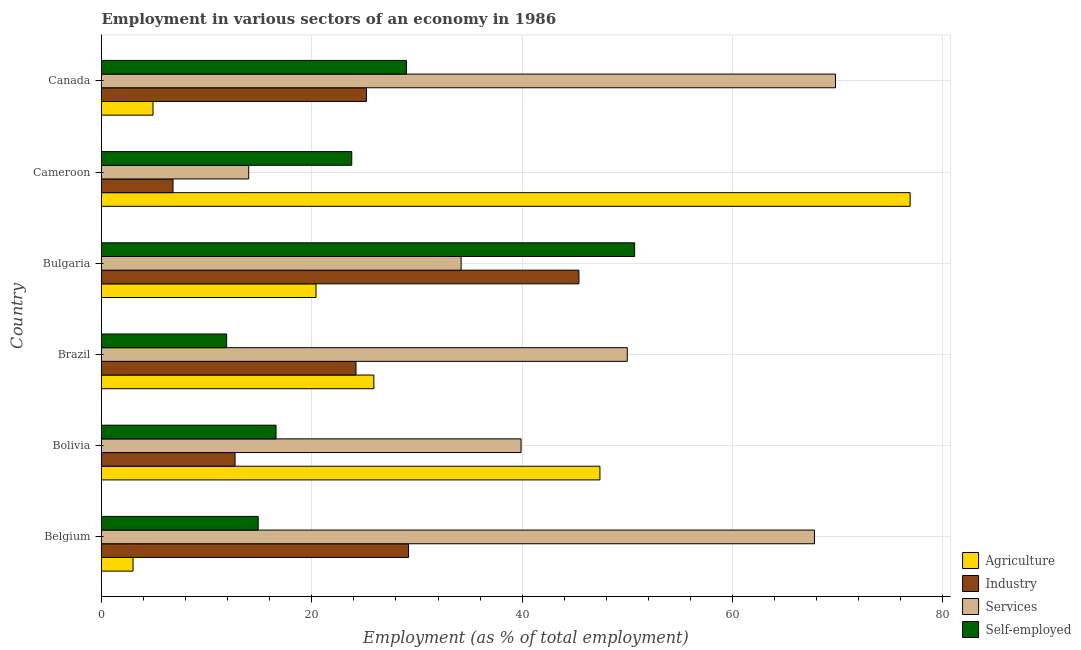How many groups of bars are there?
Ensure brevity in your answer.  6. Are the number of bars on each tick of the Y-axis equal?
Ensure brevity in your answer.  Yes. How many bars are there on the 4th tick from the bottom?
Your answer should be compact. 4. What is the label of the 5th group of bars from the top?
Your response must be concise. Bolivia. What is the percentage of self employed workers in Belgium?
Make the answer very short. 14.9. Across all countries, what is the maximum percentage of workers in industry?
Provide a short and direct response. 45.4. Across all countries, what is the minimum percentage of self employed workers?
Ensure brevity in your answer.  11.9. In which country was the percentage of workers in services maximum?
Give a very brief answer. Canada. In which country was the percentage of workers in services minimum?
Offer a terse response. Cameroon. What is the total percentage of workers in agriculture in the graph?
Make the answer very short. 178.5. What is the difference between the percentage of workers in services in Brazil and that in Canada?
Keep it short and to the point. -19.8. What is the difference between the percentage of workers in agriculture in Bulgaria and the percentage of self employed workers in Bolivia?
Provide a short and direct response. 3.8. What is the average percentage of self employed workers per country?
Offer a terse response. 24.48. What is the difference between the percentage of workers in agriculture and percentage of workers in industry in Belgium?
Offer a terse response. -26.2. What is the ratio of the percentage of workers in services in Bolivia to that in Bulgaria?
Offer a terse response. 1.17. Is the percentage of self employed workers in Brazil less than that in Bulgaria?
Your answer should be compact. Yes. Is the difference between the percentage of workers in services in Belgium and Cameroon greater than the difference between the percentage of workers in agriculture in Belgium and Cameroon?
Provide a short and direct response. Yes. What is the difference between the highest and the second highest percentage of workers in services?
Your answer should be compact. 2. What is the difference between the highest and the lowest percentage of self employed workers?
Keep it short and to the point. 38.8. In how many countries, is the percentage of self employed workers greater than the average percentage of self employed workers taken over all countries?
Offer a terse response. 2. Is the sum of the percentage of workers in services in Belgium and Bolivia greater than the maximum percentage of workers in agriculture across all countries?
Provide a short and direct response. Yes. What does the 3rd bar from the top in Cameroon represents?
Provide a short and direct response. Industry. What does the 2nd bar from the bottom in Bulgaria represents?
Make the answer very short. Industry. Is it the case that in every country, the sum of the percentage of workers in agriculture and percentage of workers in industry is greater than the percentage of workers in services?
Give a very brief answer. No. How many bars are there?
Offer a terse response. 24. How many countries are there in the graph?
Keep it short and to the point. 6. What is the difference between two consecutive major ticks on the X-axis?
Give a very brief answer. 20. Are the values on the major ticks of X-axis written in scientific E-notation?
Offer a terse response. No. Does the graph contain any zero values?
Keep it short and to the point. No. How are the legend labels stacked?
Provide a succinct answer. Vertical. What is the title of the graph?
Give a very brief answer. Employment in various sectors of an economy in 1986. Does "Secondary schools" appear as one of the legend labels in the graph?
Keep it short and to the point. No. What is the label or title of the X-axis?
Ensure brevity in your answer.  Employment (as % of total employment). What is the label or title of the Y-axis?
Keep it short and to the point. Country. What is the Employment (as % of total employment) in Industry in Belgium?
Provide a short and direct response. 29.2. What is the Employment (as % of total employment) in Services in Belgium?
Provide a succinct answer. 67.8. What is the Employment (as % of total employment) in Self-employed in Belgium?
Your answer should be compact. 14.9. What is the Employment (as % of total employment) of Agriculture in Bolivia?
Make the answer very short. 47.4. What is the Employment (as % of total employment) in Industry in Bolivia?
Provide a short and direct response. 12.7. What is the Employment (as % of total employment) in Services in Bolivia?
Provide a short and direct response. 39.9. What is the Employment (as % of total employment) in Self-employed in Bolivia?
Your response must be concise. 16.6. What is the Employment (as % of total employment) of Agriculture in Brazil?
Ensure brevity in your answer.  25.9. What is the Employment (as % of total employment) of Industry in Brazil?
Offer a very short reply. 24.2. What is the Employment (as % of total employment) of Self-employed in Brazil?
Offer a terse response. 11.9. What is the Employment (as % of total employment) of Agriculture in Bulgaria?
Offer a terse response. 20.4. What is the Employment (as % of total employment) in Industry in Bulgaria?
Provide a succinct answer. 45.4. What is the Employment (as % of total employment) of Services in Bulgaria?
Your answer should be very brief. 34.2. What is the Employment (as % of total employment) in Self-employed in Bulgaria?
Your answer should be very brief. 50.7. What is the Employment (as % of total employment) of Agriculture in Cameroon?
Your answer should be compact. 76.9. What is the Employment (as % of total employment) in Industry in Cameroon?
Ensure brevity in your answer.  6.8. What is the Employment (as % of total employment) of Self-employed in Cameroon?
Your response must be concise. 23.8. What is the Employment (as % of total employment) of Agriculture in Canada?
Make the answer very short. 4.9. What is the Employment (as % of total employment) of Industry in Canada?
Make the answer very short. 25.2. What is the Employment (as % of total employment) of Services in Canada?
Your answer should be very brief. 69.8. What is the Employment (as % of total employment) in Self-employed in Canada?
Give a very brief answer. 29. Across all countries, what is the maximum Employment (as % of total employment) of Agriculture?
Provide a succinct answer. 76.9. Across all countries, what is the maximum Employment (as % of total employment) of Industry?
Offer a terse response. 45.4. Across all countries, what is the maximum Employment (as % of total employment) in Services?
Your answer should be compact. 69.8. Across all countries, what is the maximum Employment (as % of total employment) of Self-employed?
Your answer should be compact. 50.7. Across all countries, what is the minimum Employment (as % of total employment) of Industry?
Give a very brief answer. 6.8. Across all countries, what is the minimum Employment (as % of total employment) of Services?
Keep it short and to the point. 14. Across all countries, what is the minimum Employment (as % of total employment) in Self-employed?
Offer a very short reply. 11.9. What is the total Employment (as % of total employment) of Agriculture in the graph?
Offer a terse response. 178.5. What is the total Employment (as % of total employment) of Industry in the graph?
Provide a succinct answer. 143.5. What is the total Employment (as % of total employment) of Services in the graph?
Keep it short and to the point. 275.7. What is the total Employment (as % of total employment) in Self-employed in the graph?
Your answer should be compact. 146.9. What is the difference between the Employment (as % of total employment) of Agriculture in Belgium and that in Bolivia?
Provide a succinct answer. -44.4. What is the difference between the Employment (as % of total employment) in Industry in Belgium and that in Bolivia?
Ensure brevity in your answer.  16.5. What is the difference between the Employment (as % of total employment) in Services in Belgium and that in Bolivia?
Offer a very short reply. 27.9. What is the difference between the Employment (as % of total employment) in Self-employed in Belgium and that in Bolivia?
Your response must be concise. -1.7. What is the difference between the Employment (as % of total employment) of Agriculture in Belgium and that in Brazil?
Keep it short and to the point. -22.9. What is the difference between the Employment (as % of total employment) in Agriculture in Belgium and that in Bulgaria?
Your answer should be very brief. -17.4. What is the difference between the Employment (as % of total employment) of Industry in Belgium and that in Bulgaria?
Ensure brevity in your answer.  -16.2. What is the difference between the Employment (as % of total employment) of Services in Belgium and that in Bulgaria?
Keep it short and to the point. 33.6. What is the difference between the Employment (as % of total employment) of Self-employed in Belgium and that in Bulgaria?
Give a very brief answer. -35.8. What is the difference between the Employment (as % of total employment) of Agriculture in Belgium and that in Cameroon?
Your answer should be very brief. -73.9. What is the difference between the Employment (as % of total employment) of Industry in Belgium and that in Cameroon?
Ensure brevity in your answer.  22.4. What is the difference between the Employment (as % of total employment) of Services in Belgium and that in Cameroon?
Keep it short and to the point. 53.8. What is the difference between the Employment (as % of total employment) in Self-employed in Belgium and that in Cameroon?
Offer a very short reply. -8.9. What is the difference between the Employment (as % of total employment) of Self-employed in Belgium and that in Canada?
Keep it short and to the point. -14.1. What is the difference between the Employment (as % of total employment) of Services in Bolivia and that in Brazil?
Provide a succinct answer. -10.1. What is the difference between the Employment (as % of total employment) of Agriculture in Bolivia and that in Bulgaria?
Give a very brief answer. 27. What is the difference between the Employment (as % of total employment) in Industry in Bolivia and that in Bulgaria?
Provide a succinct answer. -32.7. What is the difference between the Employment (as % of total employment) of Services in Bolivia and that in Bulgaria?
Your response must be concise. 5.7. What is the difference between the Employment (as % of total employment) in Self-employed in Bolivia and that in Bulgaria?
Offer a very short reply. -34.1. What is the difference between the Employment (as % of total employment) of Agriculture in Bolivia and that in Cameroon?
Offer a very short reply. -29.5. What is the difference between the Employment (as % of total employment) in Services in Bolivia and that in Cameroon?
Ensure brevity in your answer.  25.9. What is the difference between the Employment (as % of total employment) in Agriculture in Bolivia and that in Canada?
Make the answer very short. 42.5. What is the difference between the Employment (as % of total employment) in Services in Bolivia and that in Canada?
Your answer should be very brief. -29.9. What is the difference between the Employment (as % of total employment) in Self-employed in Bolivia and that in Canada?
Keep it short and to the point. -12.4. What is the difference between the Employment (as % of total employment) in Agriculture in Brazil and that in Bulgaria?
Give a very brief answer. 5.5. What is the difference between the Employment (as % of total employment) of Industry in Brazil and that in Bulgaria?
Ensure brevity in your answer.  -21.2. What is the difference between the Employment (as % of total employment) of Self-employed in Brazil and that in Bulgaria?
Your answer should be very brief. -38.8. What is the difference between the Employment (as % of total employment) in Agriculture in Brazil and that in Cameroon?
Your response must be concise. -51. What is the difference between the Employment (as % of total employment) of Agriculture in Brazil and that in Canada?
Offer a terse response. 21. What is the difference between the Employment (as % of total employment) of Industry in Brazil and that in Canada?
Your answer should be very brief. -1. What is the difference between the Employment (as % of total employment) of Services in Brazil and that in Canada?
Offer a very short reply. -19.8. What is the difference between the Employment (as % of total employment) in Self-employed in Brazil and that in Canada?
Your response must be concise. -17.1. What is the difference between the Employment (as % of total employment) of Agriculture in Bulgaria and that in Cameroon?
Your answer should be very brief. -56.5. What is the difference between the Employment (as % of total employment) in Industry in Bulgaria and that in Cameroon?
Keep it short and to the point. 38.6. What is the difference between the Employment (as % of total employment) in Services in Bulgaria and that in Cameroon?
Ensure brevity in your answer.  20.2. What is the difference between the Employment (as % of total employment) in Self-employed in Bulgaria and that in Cameroon?
Ensure brevity in your answer.  26.9. What is the difference between the Employment (as % of total employment) of Agriculture in Bulgaria and that in Canada?
Your answer should be compact. 15.5. What is the difference between the Employment (as % of total employment) in Industry in Bulgaria and that in Canada?
Your answer should be compact. 20.2. What is the difference between the Employment (as % of total employment) of Services in Bulgaria and that in Canada?
Offer a very short reply. -35.6. What is the difference between the Employment (as % of total employment) of Self-employed in Bulgaria and that in Canada?
Give a very brief answer. 21.7. What is the difference between the Employment (as % of total employment) in Agriculture in Cameroon and that in Canada?
Make the answer very short. 72. What is the difference between the Employment (as % of total employment) of Industry in Cameroon and that in Canada?
Give a very brief answer. -18.4. What is the difference between the Employment (as % of total employment) in Services in Cameroon and that in Canada?
Provide a succinct answer. -55.8. What is the difference between the Employment (as % of total employment) of Self-employed in Cameroon and that in Canada?
Provide a succinct answer. -5.2. What is the difference between the Employment (as % of total employment) in Agriculture in Belgium and the Employment (as % of total employment) in Services in Bolivia?
Provide a short and direct response. -36.9. What is the difference between the Employment (as % of total employment) of Agriculture in Belgium and the Employment (as % of total employment) of Self-employed in Bolivia?
Your answer should be compact. -13.6. What is the difference between the Employment (as % of total employment) in Industry in Belgium and the Employment (as % of total employment) in Self-employed in Bolivia?
Your answer should be compact. 12.6. What is the difference between the Employment (as % of total employment) of Services in Belgium and the Employment (as % of total employment) of Self-employed in Bolivia?
Offer a very short reply. 51.2. What is the difference between the Employment (as % of total employment) in Agriculture in Belgium and the Employment (as % of total employment) in Industry in Brazil?
Offer a very short reply. -21.2. What is the difference between the Employment (as % of total employment) in Agriculture in Belgium and the Employment (as % of total employment) in Services in Brazil?
Your response must be concise. -47. What is the difference between the Employment (as % of total employment) of Industry in Belgium and the Employment (as % of total employment) of Services in Brazil?
Your response must be concise. -20.8. What is the difference between the Employment (as % of total employment) of Services in Belgium and the Employment (as % of total employment) of Self-employed in Brazil?
Provide a succinct answer. 55.9. What is the difference between the Employment (as % of total employment) in Agriculture in Belgium and the Employment (as % of total employment) in Industry in Bulgaria?
Offer a terse response. -42.4. What is the difference between the Employment (as % of total employment) of Agriculture in Belgium and the Employment (as % of total employment) of Services in Bulgaria?
Your answer should be very brief. -31.2. What is the difference between the Employment (as % of total employment) in Agriculture in Belgium and the Employment (as % of total employment) in Self-employed in Bulgaria?
Make the answer very short. -47.7. What is the difference between the Employment (as % of total employment) in Industry in Belgium and the Employment (as % of total employment) in Services in Bulgaria?
Give a very brief answer. -5. What is the difference between the Employment (as % of total employment) in Industry in Belgium and the Employment (as % of total employment) in Self-employed in Bulgaria?
Provide a succinct answer. -21.5. What is the difference between the Employment (as % of total employment) of Agriculture in Belgium and the Employment (as % of total employment) of Self-employed in Cameroon?
Make the answer very short. -20.8. What is the difference between the Employment (as % of total employment) of Industry in Belgium and the Employment (as % of total employment) of Self-employed in Cameroon?
Ensure brevity in your answer.  5.4. What is the difference between the Employment (as % of total employment) in Agriculture in Belgium and the Employment (as % of total employment) in Industry in Canada?
Your response must be concise. -22.2. What is the difference between the Employment (as % of total employment) in Agriculture in Belgium and the Employment (as % of total employment) in Services in Canada?
Provide a succinct answer. -66.8. What is the difference between the Employment (as % of total employment) in Industry in Belgium and the Employment (as % of total employment) in Services in Canada?
Your answer should be compact. -40.6. What is the difference between the Employment (as % of total employment) in Services in Belgium and the Employment (as % of total employment) in Self-employed in Canada?
Your response must be concise. 38.8. What is the difference between the Employment (as % of total employment) of Agriculture in Bolivia and the Employment (as % of total employment) of Industry in Brazil?
Provide a succinct answer. 23.2. What is the difference between the Employment (as % of total employment) of Agriculture in Bolivia and the Employment (as % of total employment) of Self-employed in Brazil?
Your answer should be compact. 35.5. What is the difference between the Employment (as % of total employment) in Industry in Bolivia and the Employment (as % of total employment) in Services in Brazil?
Keep it short and to the point. -37.3. What is the difference between the Employment (as % of total employment) in Industry in Bolivia and the Employment (as % of total employment) in Self-employed in Brazil?
Give a very brief answer. 0.8. What is the difference between the Employment (as % of total employment) of Agriculture in Bolivia and the Employment (as % of total employment) of Services in Bulgaria?
Offer a terse response. 13.2. What is the difference between the Employment (as % of total employment) of Industry in Bolivia and the Employment (as % of total employment) of Services in Bulgaria?
Provide a short and direct response. -21.5. What is the difference between the Employment (as % of total employment) in Industry in Bolivia and the Employment (as % of total employment) in Self-employed in Bulgaria?
Your response must be concise. -38. What is the difference between the Employment (as % of total employment) in Agriculture in Bolivia and the Employment (as % of total employment) in Industry in Cameroon?
Make the answer very short. 40.6. What is the difference between the Employment (as % of total employment) in Agriculture in Bolivia and the Employment (as % of total employment) in Services in Cameroon?
Make the answer very short. 33.4. What is the difference between the Employment (as % of total employment) of Agriculture in Bolivia and the Employment (as % of total employment) of Self-employed in Cameroon?
Your answer should be very brief. 23.6. What is the difference between the Employment (as % of total employment) in Agriculture in Bolivia and the Employment (as % of total employment) in Industry in Canada?
Your response must be concise. 22.2. What is the difference between the Employment (as % of total employment) of Agriculture in Bolivia and the Employment (as % of total employment) of Services in Canada?
Ensure brevity in your answer.  -22.4. What is the difference between the Employment (as % of total employment) of Industry in Bolivia and the Employment (as % of total employment) of Services in Canada?
Offer a terse response. -57.1. What is the difference between the Employment (as % of total employment) of Industry in Bolivia and the Employment (as % of total employment) of Self-employed in Canada?
Ensure brevity in your answer.  -16.3. What is the difference between the Employment (as % of total employment) in Services in Bolivia and the Employment (as % of total employment) in Self-employed in Canada?
Provide a succinct answer. 10.9. What is the difference between the Employment (as % of total employment) of Agriculture in Brazil and the Employment (as % of total employment) of Industry in Bulgaria?
Offer a very short reply. -19.5. What is the difference between the Employment (as % of total employment) in Agriculture in Brazil and the Employment (as % of total employment) in Services in Bulgaria?
Your response must be concise. -8.3. What is the difference between the Employment (as % of total employment) of Agriculture in Brazil and the Employment (as % of total employment) of Self-employed in Bulgaria?
Your answer should be compact. -24.8. What is the difference between the Employment (as % of total employment) in Industry in Brazil and the Employment (as % of total employment) in Services in Bulgaria?
Your response must be concise. -10. What is the difference between the Employment (as % of total employment) of Industry in Brazil and the Employment (as % of total employment) of Self-employed in Bulgaria?
Ensure brevity in your answer.  -26.5. What is the difference between the Employment (as % of total employment) of Agriculture in Brazil and the Employment (as % of total employment) of Industry in Cameroon?
Give a very brief answer. 19.1. What is the difference between the Employment (as % of total employment) in Agriculture in Brazil and the Employment (as % of total employment) in Self-employed in Cameroon?
Your response must be concise. 2.1. What is the difference between the Employment (as % of total employment) of Industry in Brazil and the Employment (as % of total employment) of Self-employed in Cameroon?
Your response must be concise. 0.4. What is the difference between the Employment (as % of total employment) in Services in Brazil and the Employment (as % of total employment) in Self-employed in Cameroon?
Offer a very short reply. 26.2. What is the difference between the Employment (as % of total employment) in Agriculture in Brazil and the Employment (as % of total employment) in Industry in Canada?
Your answer should be compact. 0.7. What is the difference between the Employment (as % of total employment) of Agriculture in Brazil and the Employment (as % of total employment) of Services in Canada?
Offer a very short reply. -43.9. What is the difference between the Employment (as % of total employment) in Industry in Brazil and the Employment (as % of total employment) in Services in Canada?
Ensure brevity in your answer.  -45.6. What is the difference between the Employment (as % of total employment) of Agriculture in Bulgaria and the Employment (as % of total employment) of Industry in Cameroon?
Your answer should be very brief. 13.6. What is the difference between the Employment (as % of total employment) in Agriculture in Bulgaria and the Employment (as % of total employment) in Services in Cameroon?
Keep it short and to the point. 6.4. What is the difference between the Employment (as % of total employment) in Agriculture in Bulgaria and the Employment (as % of total employment) in Self-employed in Cameroon?
Give a very brief answer. -3.4. What is the difference between the Employment (as % of total employment) in Industry in Bulgaria and the Employment (as % of total employment) in Services in Cameroon?
Offer a very short reply. 31.4. What is the difference between the Employment (as % of total employment) in Industry in Bulgaria and the Employment (as % of total employment) in Self-employed in Cameroon?
Your answer should be compact. 21.6. What is the difference between the Employment (as % of total employment) of Agriculture in Bulgaria and the Employment (as % of total employment) of Industry in Canada?
Ensure brevity in your answer.  -4.8. What is the difference between the Employment (as % of total employment) in Agriculture in Bulgaria and the Employment (as % of total employment) in Services in Canada?
Your answer should be compact. -49.4. What is the difference between the Employment (as % of total employment) in Industry in Bulgaria and the Employment (as % of total employment) in Services in Canada?
Provide a succinct answer. -24.4. What is the difference between the Employment (as % of total employment) in Agriculture in Cameroon and the Employment (as % of total employment) in Industry in Canada?
Offer a very short reply. 51.7. What is the difference between the Employment (as % of total employment) of Agriculture in Cameroon and the Employment (as % of total employment) of Self-employed in Canada?
Make the answer very short. 47.9. What is the difference between the Employment (as % of total employment) in Industry in Cameroon and the Employment (as % of total employment) in Services in Canada?
Your response must be concise. -63. What is the difference between the Employment (as % of total employment) in Industry in Cameroon and the Employment (as % of total employment) in Self-employed in Canada?
Give a very brief answer. -22.2. What is the average Employment (as % of total employment) of Agriculture per country?
Give a very brief answer. 29.75. What is the average Employment (as % of total employment) in Industry per country?
Your answer should be very brief. 23.92. What is the average Employment (as % of total employment) of Services per country?
Your answer should be compact. 45.95. What is the average Employment (as % of total employment) in Self-employed per country?
Ensure brevity in your answer.  24.48. What is the difference between the Employment (as % of total employment) of Agriculture and Employment (as % of total employment) of Industry in Belgium?
Your answer should be very brief. -26.2. What is the difference between the Employment (as % of total employment) of Agriculture and Employment (as % of total employment) of Services in Belgium?
Offer a very short reply. -64.8. What is the difference between the Employment (as % of total employment) in Industry and Employment (as % of total employment) in Services in Belgium?
Your answer should be compact. -38.6. What is the difference between the Employment (as % of total employment) in Services and Employment (as % of total employment) in Self-employed in Belgium?
Offer a very short reply. 52.9. What is the difference between the Employment (as % of total employment) in Agriculture and Employment (as % of total employment) in Industry in Bolivia?
Your answer should be very brief. 34.7. What is the difference between the Employment (as % of total employment) of Agriculture and Employment (as % of total employment) of Self-employed in Bolivia?
Your response must be concise. 30.8. What is the difference between the Employment (as % of total employment) in Industry and Employment (as % of total employment) in Services in Bolivia?
Your answer should be compact. -27.2. What is the difference between the Employment (as % of total employment) of Services and Employment (as % of total employment) of Self-employed in Bolivia?
Offer a very short reply. 23.3. What is the difference between the Employment (as % of total employment) in Agriculture and Employment (as % of total employment) in Services in Brazil?
Offer a very short reply. -24.1. What is the difference between the Employment (as % of total employment) of Agriculture and Employment (as % of total employment) of Self-employed in Brazil?
Your response must be concise. 14. What is the difference between the Employment (as % of total employment) of Industry and Employment (as % of total employment) of Services in Brazil?
Provide a succinct answer. -25.8. What is the difference between the Employment (as % of total employment) in Services and Employment (as % of total employment) in Self-employed in Brazil?
Make the answer very short. 38.1. What is the difference between the Employment (as % of total employment) of Agriculture and Employment (as % of total employment) of Industry in Bulgaria?
Offer a terse response. -25. What is the difference between the Employment (as % of total employment) in Agriculture and Employment (as % of total employment) in Services in Bulgaria?
Offer a very short reply. -13.8. What is the difference between the Employment (as % of total employment) in Agriculture and Employment (as % of total employment) in Self-employed in Bulgaria?
Keep it short and to the point. -30.3. What is the difference between the Employment (as % of total employment) of Industry and Employment (as % of total employment) of Services in Bulgaria?
Provide a succinct answer. 11.2. What is the difference between the Employment (as % of total employment) in Industry and Employment (as % of total employment) in Self-employed in Bulgaria?
Ensure brevity in your answer.  -5.3. What is the difference between the Employment (as % of total employment) of Services and Employment (as % of total employment) of Self-employed in Bulgaria?
Your answer should be very brief. -16.5. What is the difference between the Employment (as % of total employment) of Agriculture and Employment (as % of total employment) of Industry in Cameroon?
Offer a terse response. 70.1. What is the difference between the Employment (as % of total employment) of Agriculture and Employment (as % of total employment) of Services in Cameroon?
Your response must be concise. 62.9. What is the difference between the Employment (as % of total employment) of Agriculture and Employment (as % of total employment) of Self-employed in Cameroon?
Your response must be concise. 53.1. What is the difference between the Employment (as % of total employment) of Industry and Employment (as % of total employment) of Self-employed in Cameroon?
Ensure brevity in your answer.  -17. What is the difference between the Employment (as % of total employment) of Agriculture and Employment (as % of total employment) of Industry in Canada?
Provide a short and direct response. -20.3. What is the difference between the Employment (as % of total employment) of Agriculture and Employment (as % of total employment) of Services in Canada?
Your answer should be compact. -64.9. What is the difference between the Employment (as % of total employment) of Agriculture and Employment (as % of total employment) of Self-employed in Canada?
Keep it short and to the point. -24.1. What is the difference between the Employment (as % of total employment) of Industry and Employment (as % of total employment) of Services in Canada?
Make the answer very short. -44.6. What is the difference between the Employment (as % of total employment) in Services and Employment (as % of total employment) in Self-employed in Canada?
Provide a short and direct response. 40.8. What is the ratio of the Employment (as % of total employment) of Agriculture in Belgium to that in Bolivia?
Keep it short and to the point. 0.06. What is the ratio of the Employment (as % of total employment) of Industry in Belgium to that in Bolivia?
Provide a succinct answer. 2.3. What is the ratio of the Employment (as % of total employment) of Services in Belgium to that in Bolivia?
Give a very brief answer. 1.7. What is the ratio of the Employment (as % of total employment) in Self-employed in Belgium to that in Bolivia?
Ensure brevity in your answer.  0.9. What is the ratio of the Employment (as % of total employment) of Agriculture in Belgium to that in Brazil?
Your answer should be very brief. 0.12. What is the ratio of the Employment (as % of total employment) in Industry in Belgium to that in Brazil?
Offer a terse response. 1.21. What is the ratio of the Employment (as % of total employment) of Services in Belgium to that in Brazil?
Keep it short and to the point. 1.36. What is the ratio of the Employment (as % of total employment) of Self-employed in Belgium to that in Brazil?
Make the answer very short. 1.25. What is the ratio of the Employment (as % of total employment) of Agriculture in Belgium to that in Bulgaria?
Your answer should be very brief. 0.15. What is the ratio of the Employment (as % of total employment) in Industry in Belgium to that in Bulgaria?
Your response must be concise. 0.64. What is the ratio of the Employment (as % of total employment) in Services in Belgium to that in Bulgaria?
Provide a short and direct response. 1.98. What is the ratio of the Employment (as % of total employment) in Self-employed in Belgium to that in Bulgaria?
Provide a succinct answer. 0.29. What is the ratio of the Employment (as % of total employment) in Agriculture in Belgium to that in Cameroon?
Your answer should be very brief. 0.04. What is the ratio of the Employment (as % of total employment) in Industry in Belgium to that in Cameroon?
Ensure brevity in your answer.  4.29. What is the ratio of the Employment (as % of total employment) of Services in Belgium to that in Cameroon?
Provide a short and direct response. 4.84. What is the ratio of the Employment (as % of total employment) of Self-employed in Belgium to that in Cameroon?
Your answer should be very brief. 0.63. What is the ratio of the Employment (as % of total employment) in Agriculture in Belgium to that in Canada?
Provide a short and direct response. 0.61. What is the ratio of the Employment (as % of total employment) of Industry in Belgium to that in Canada?
Provide a succinct answer. 1.16. What is the ratio of the Employment (as % of total employment) of Services in Belgium to that in Canada?
Give a very brief answer. 0.97. What is the ratio of the Employment (as % of total employment) in Self-employed in Belgium to that in Canada?
Keep it short and to the point. 0.51. What is the ratio of the Employment (as % of total employment) of Agriculture in Bolivia to that in Brazil?
Your answer should be compact. 1.83. What is the ratio of the Employment (as % of total employment) in Industry in Bolivia to that in Brazil?
Your response must be concise. 0.52. What is the ratio of the Employment (as % of total employment) of Services in Bolivia to that in Brazil?
Your answer should be compact. 0.8. What is the ratio of the Employment (as % of total employment) in Self-employed in Bolivia to that in Brazil?
Provide a succinct answer. 1.4. What is the ratio of the Employment (as % of total employment) of Agriculture in Bolivia to that in Bulgaria?
Make the answer very short. 2.32. What is the ratio of the Employment (as % of total employment) of Industry in Bolivia to that in Bulgaria?
Keep it short and to the point. 0.28. What is the ratio of the Employment (as % of total employment) of Self-employed in Bolivia to that in Bulgaria?
Offer a terse response. 0.33. What is the ratio of the Employment (as % of total employment) of Agriculture in Bolivia to that in Cameroon?
Keep it short and to the point. 0.62. What is the ratio of the Employment (as % of total employment) in Industry in Bolivia to that in Cameroon?
Keep it short and to the point. 1.87. What is the ratio of the Employment (as % of total employment) in Services in Bolivia to that in Cameroon?
Provide a short and direct response. 2.85. What is the ratio of the Employment (as % of total employment) of Self-employed in Bolivia to that in Cameroon?
Offer a terse response. 0.7. What is the ratio of the Employment (as % of total employment) in Agriculture in Bolivia to that in Canada?
Ensure brevity in your answer.  9.67. What is the ratio of the Employment (as % of total employment) in Industry in Bolivia to that in Canada?
Give a very brief answer. 0.5. What is the ratio of the Employment (as % of total employment) of Services in Bolivia to that in Canada?
Ensure brevity in your answer.  0.57. What is the ratio of the Employment (as % of total employment) in Self-employed in Bolivia to that in Canada?
Give a very brief answer. 0.57. What is the ratio of the Employment (as % of total employment) of Agriculture in Brazil to that in Bulgaria?
Offer a very short reply. 1.27. What is the ratio of the Employment (as % of total employment) of Industry in Brazil to that in Bulgaria?
Your answer should be very brief. 0.53. What is the ratio of the Employment (as % of total employment) in Services in Brazil to that in Bulgaria?
Offer a very short reply. 1.46. What is the ratio of the Employment (as % of total employment) in Self-employed in Brazil to that in Bulgaria?
Provide a short and direct response. 0.23. What is the ratio of the Employment (as % of total employment) in Agriculture in Brazil to that in Cameroon?
Make the answer very short. 0.34. What is the ratio of the Employment (as % of total employment) in Industry in Brazil to that in Cameroon?
Keep it short and to the point. 3.56. What is the ratio of the Employment (as % of total employment) in Services in Brazil to that in Cameroon?
Provide a short and direct response. 3.57. What is the ratio of the Employment (as % of total employment) of Agriculture in Brazil to that in Canada?
Give a very brief answer. 5.29. What is the ratio of the Employment (as % of total employment) of Industry in Brazil to that in Canada?
Your answer should be compact. 0.96. What is the ratio of the Employment (as % of total employment) of Services in Brazil to that in Canada?
Give a very brief answer. 0.72. What is the ratio of the Employment (as % of total employment) in Self-employed in Brazil to that in Canada?
Offer a very short reply. 0.41. What is the ratio of the Employment (as % of total employment) of Agriculture in Bulgaria to that in Cameroon?
Make the answer very short. 0.27. What is the ratio of the Employment (as % of total employment) in Industry in Bulgaria to that in Cameroon?
Offer a very short reply. 6.68. What is the ratio of the Employment (as % of total employment) of Services in Bulgaria to that in Cameroon?
Offer a terse response. 2.44. What is the ratio of the Employment (as % of total employment) of Self-employed in Bulgaria to that in Cameroon?
Offer a terse response. 2.13. What is the ratio of the Employment (as % of total employment) of Agriculture in Bulgaria to that in Canada?
Offer a very short reply. 4.16. What is the ratio of the Employment (as % of total employment) in Industry in Bulgaria to that in Canada?
Make the answer very short. 1.8. What is the ratio of the Employment (as % of total employment) in Services in Bulgaria to that in Canada?
Your answer should be compact. 0.49. What is the ratio of the Employment (as % of total employment) of Self-employed in Bulgaria to that in Canada?
Your answer should be compact. 1.75. What is the ratio of the Employment (as % of total employment) of Agriculture in Cameroon to that in Canada?
Make the answer very short. 15.69. What is the ratio of the Employment (as % of total employment) of Industry in Cameroon to that in Canada?
Your answer should be compact. 0.27. What is the ratio of the Employment (as % of total employment) in Services in Cameroon to that in Canada?
Provide a succinct answer. 0.2. What is the ratio of the Employment (as % of total employment) of Self-employed in Cameroon to that in Canada?
Offer a very short reply. 0.82. What is the difference between the highest and the second highest Employment (as % of total employment) of Agriculture?
Keep it short and to the point. 29.5. What is the difference between the highest and the second highest Employment (as % of total employment) in Industry?
Make the answer very short. 16.2. What is the difference between the highest and the second highest Employment (as % of total employment) of Services?
Offer a very short reply. 2. What is the difference between the highest and the second highest Employment (as % of total employment) in Self-employed?
Your response must be concise. 21.7. What is the difference between the highest and the lowest Employment (as % of total employment) in Agriculture?
Keep it short and to the point. 73.9. What is the difference between the highest and the lowest Employment (as % of total employment) in Industry?
Keep it short and to the point. 38.6. What is the difference between the highest and the lowest Employment (as % of total employment) of Services?
Ensure brevity in your answer.  55.8. What is the difference between the highest and the lowest Employment (as % of total employment) in Self-employed?
Ensure brevity in your answer.  38.8. 